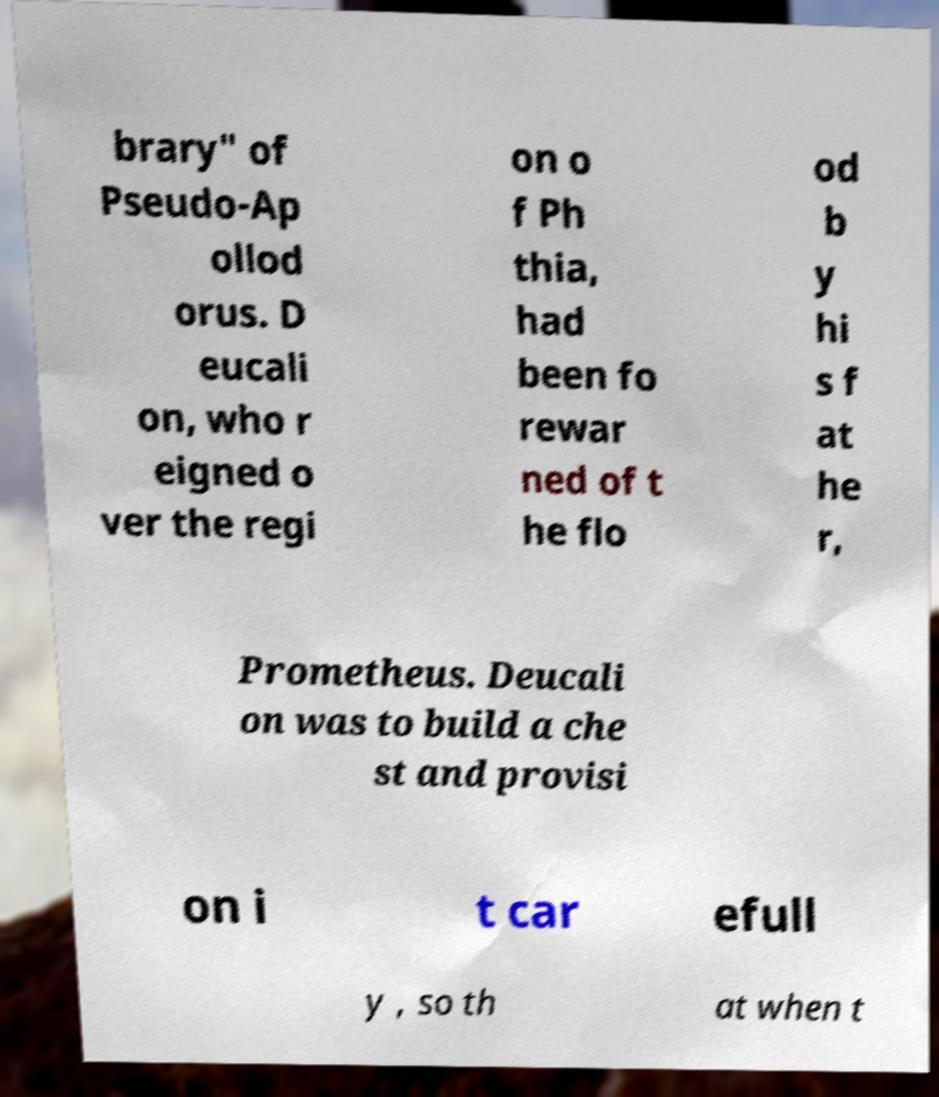Please identify and transcribe the text found in this image. brary" of Pseudo-Ap ollod orus. D eucali on, who r eigned o ver the regi on o f Ph thia, had been fo rewar ned of t he flo od b y hi s f at he r, Prometheus. Deucali on was to build a che st and provisi on i t car efull y , so th at when t 